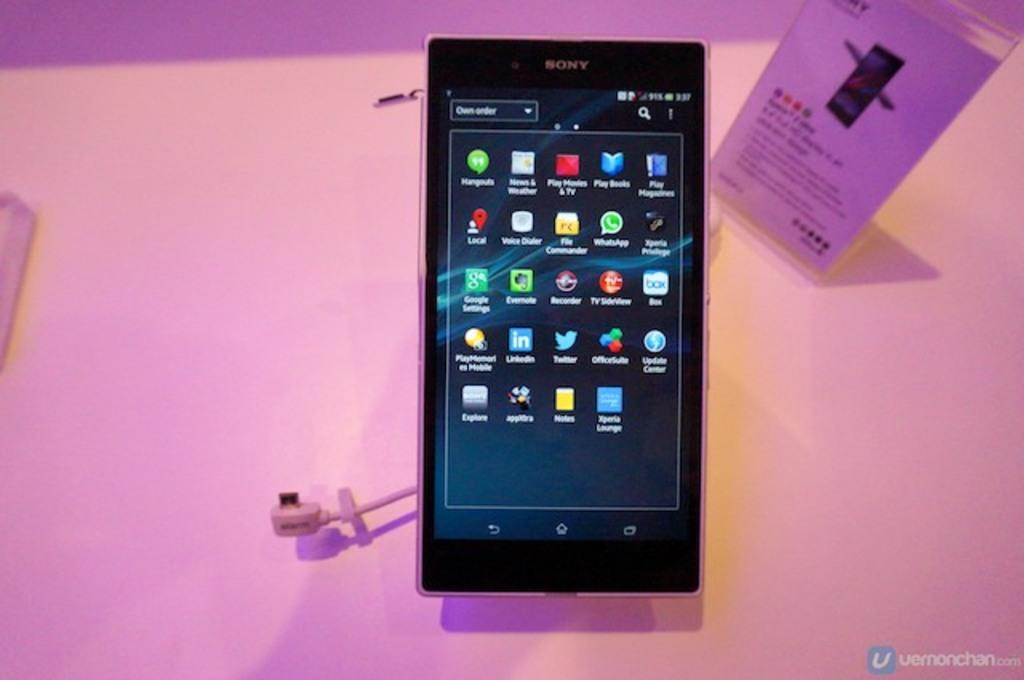Provide a one-sentence caption for the provided image. A cell phone displaying different apps including Play Books and Play Movies & TV. 